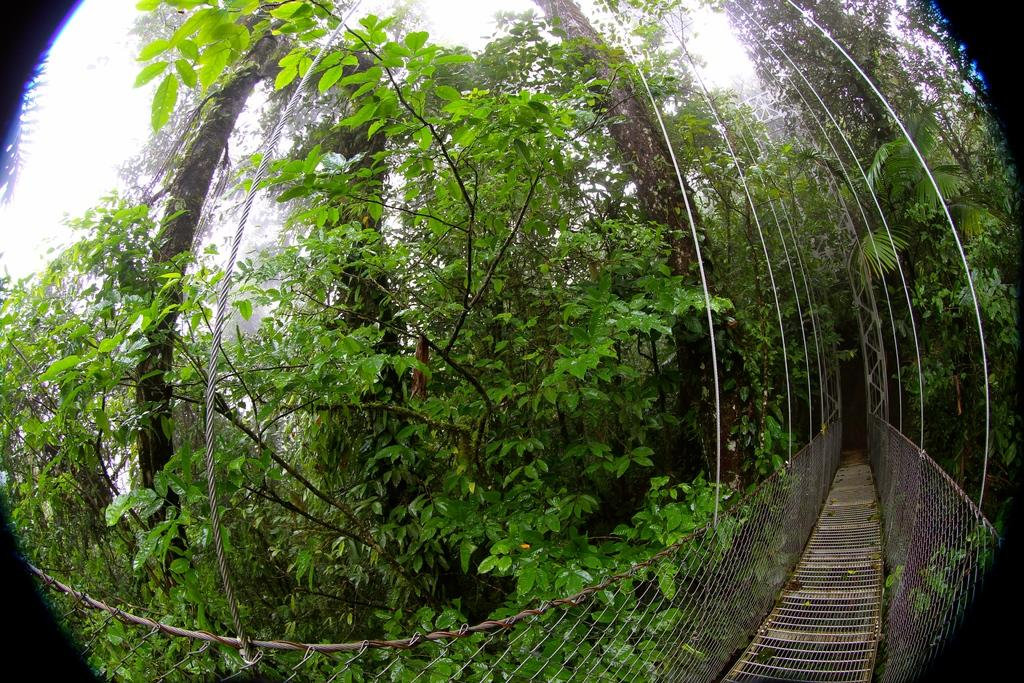What structure is the main subject of the image? There is a bridge in the image. What feature does the bridge have? The bridge has a fence. What can be seen in the background of the image? There are trees and the sky visible in the background of the image. How many turkeys can be seen on the bridge in the image? There are no turkeys present in the image; it features a bridge with a fence. What type of wall is visible on the bridge in the image? There is no wall visible on the bridge in the image; it has a fence instead. 